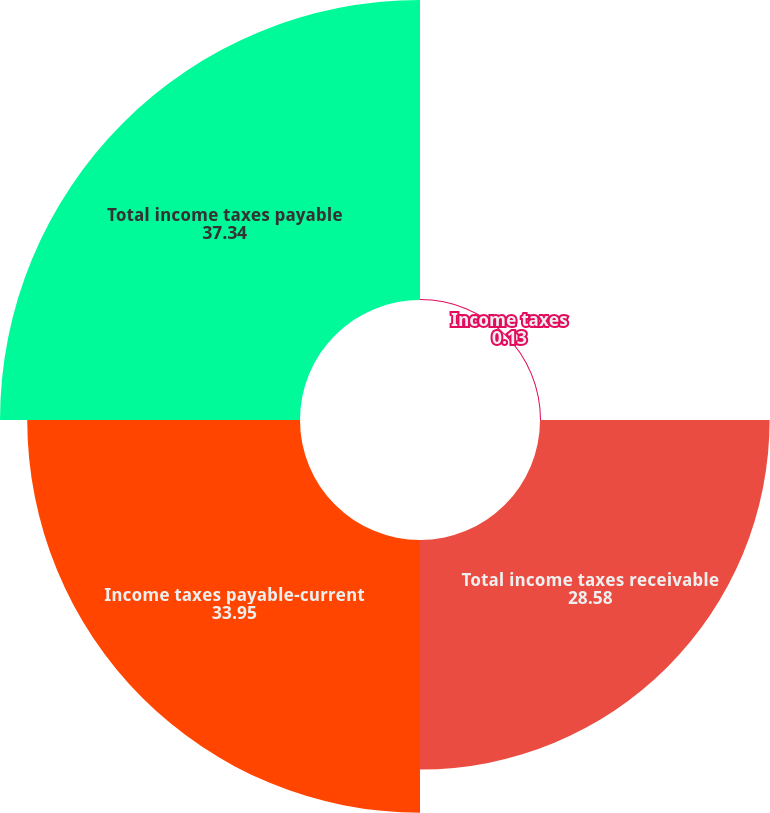Convert chart to OTSL. <chart><loc_0><loc_0><loc_500><loc_500><pie_chart><fcel>Income taxes<fcel>Total income taxes receivable<fcel>Income taxes payable-current<fcel>Total income taxes payable<nl><fcel>0.13%<fcel>28.58%<fcel>33.95%<fcel>37.34%<nl></chart> 